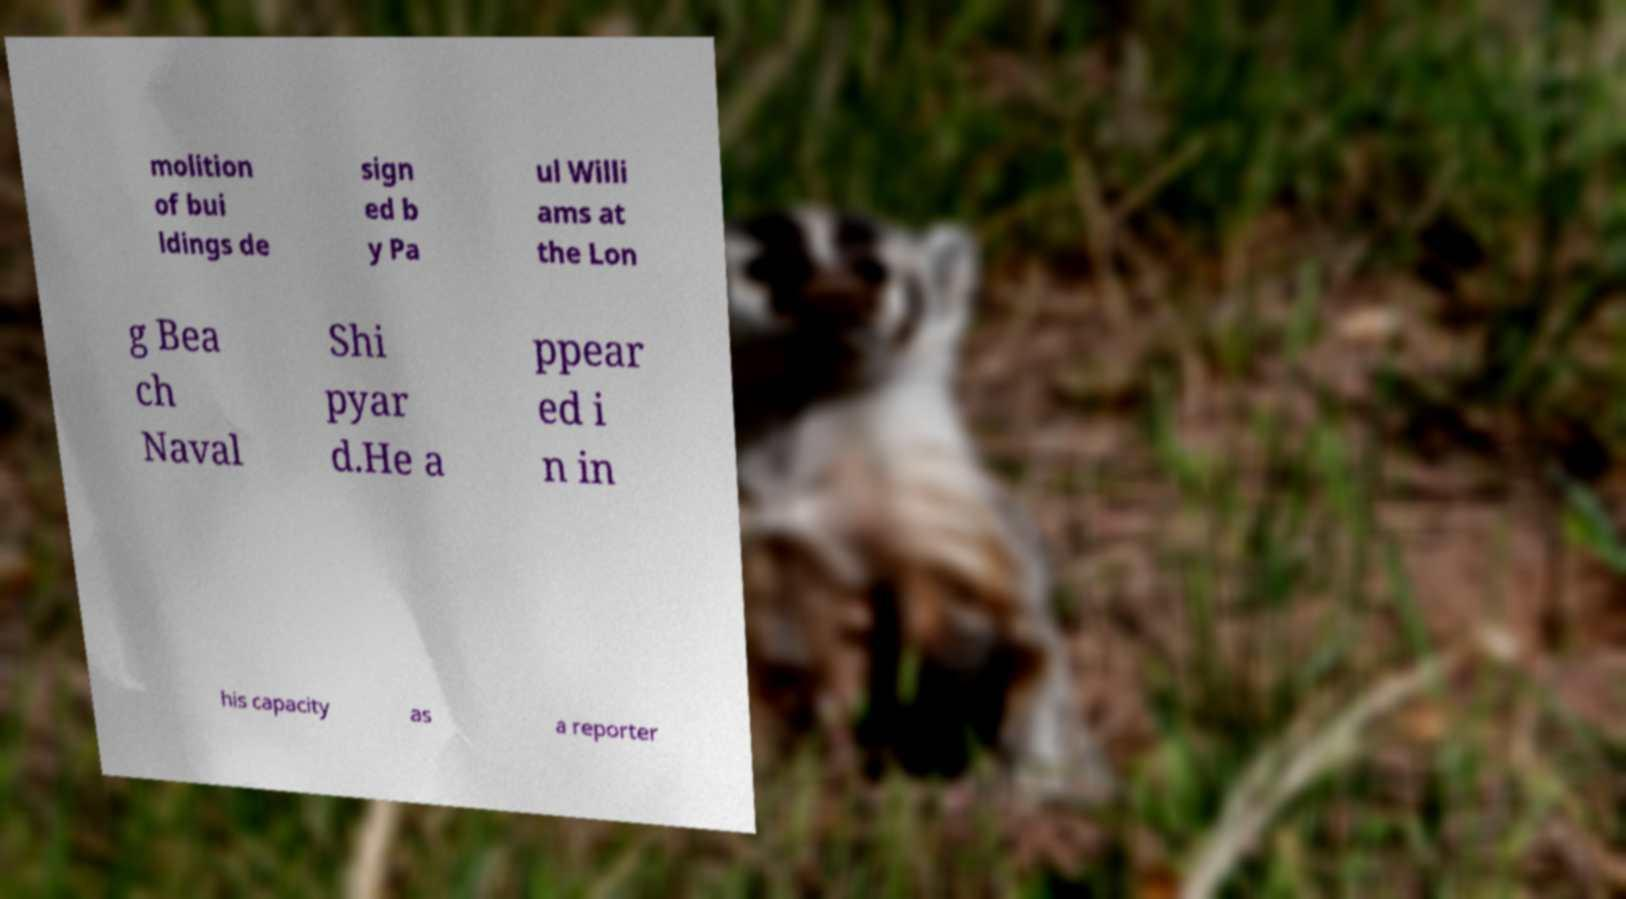Please identify and transcribe the text found in this image. molition of bui ldings de sign ed b y Pa ul Willi ams at the Lon g Bea ch Naval Shi pyar d.He a ppear ed i n in his capacity as a reporter 